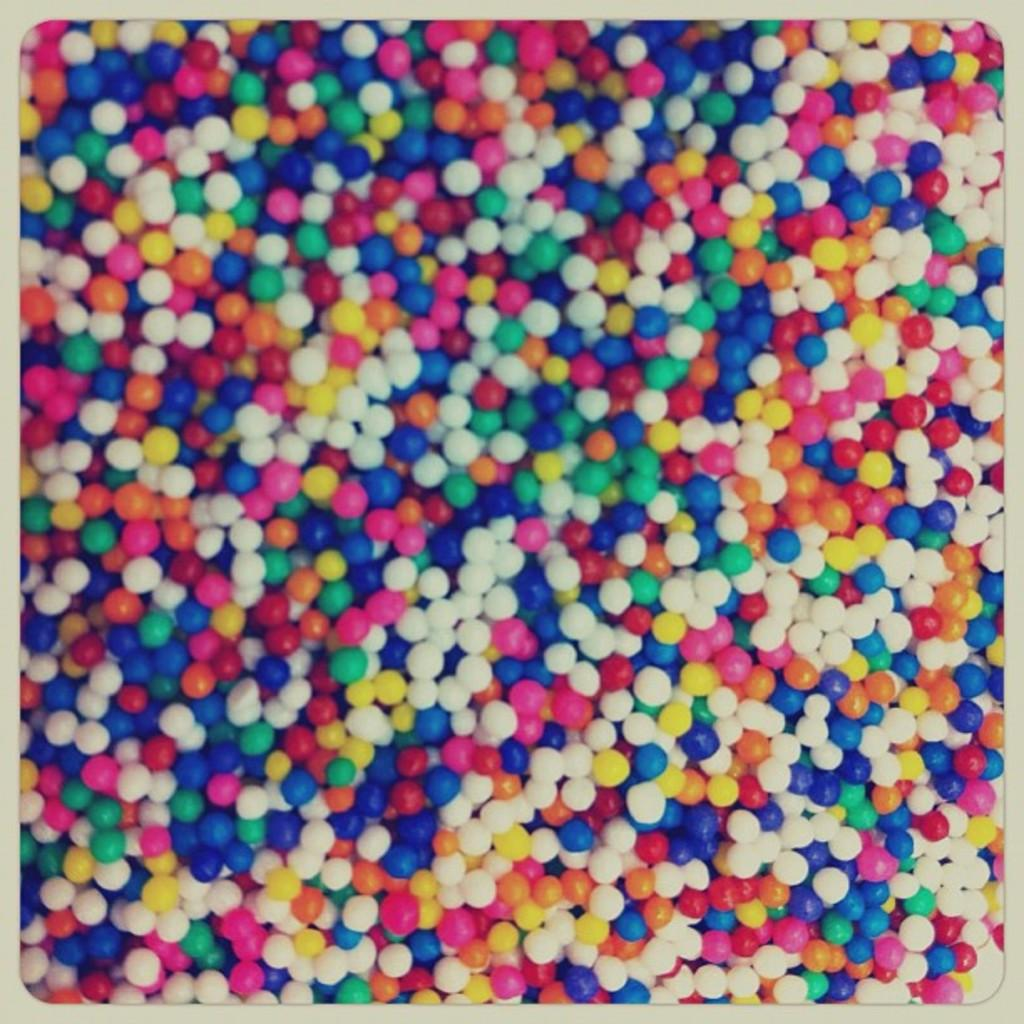What objects are present in the image? There is a group of colorful balls in the image. Can you describe the appearance of the balls? The balls are colorful, which suggests they come in various hues. How many balls are in the group? The number of balls in the group cannot be determined from the provided facts. Where is the garden with flowers located in the image? There is no garden or flowers present in the image; it features a group of colorful balls. 